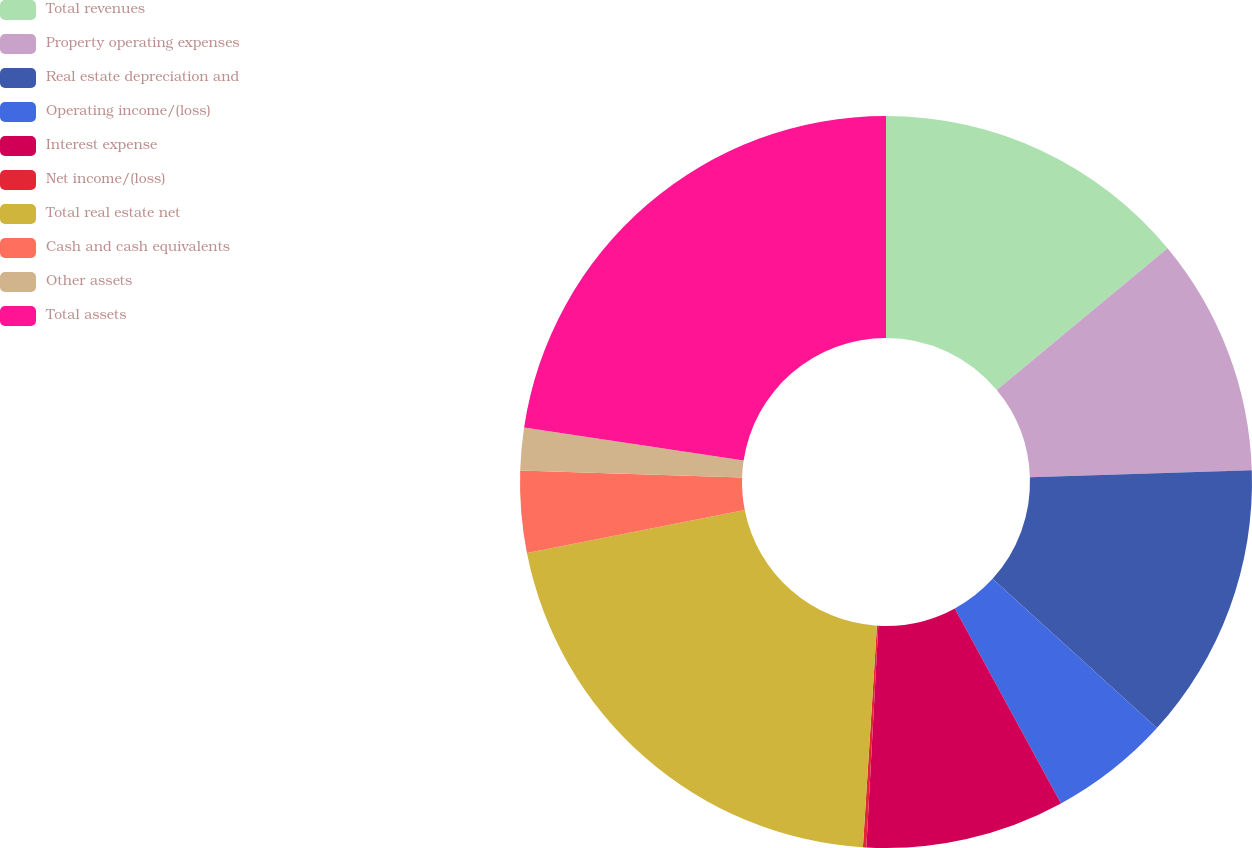<chart> <loc_0><loc_0><loc_500><loc_500><pie_chart><fcel>Total revenues<fcel>Property operating expenses<fcel>Real estate depreciation and<fcel>Operating income/(loss)<fcel>Interest expense<fcel>Net income/(loss)<fcel>Total real estate net<fcel>Cash and cash equivalents<fcel>Other assets<fcel>Total assets<nl><fcel>13.97%<fcel>10.52%<fcel>12.25%<fcel>5.33%<fcel>8.79%<fcel>0.15%<fcel>20.89%<fcel>3.61%<fcel>1.88%<fcel>22.62%<nl></chart> 